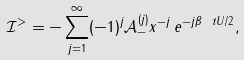<formula> <loc_0><loc_0><loc_500><loc_500>\mathcal { I } ^ { > } = - \sum _ { j = 1 } ^ { \infty } ( - 1 ) ^ { j } \mathcal { A } _ { - } ^ { ( j ) } x ^ { - j } \, e ^ { - j \beta \ t { U } / 2 } ,</formula> 